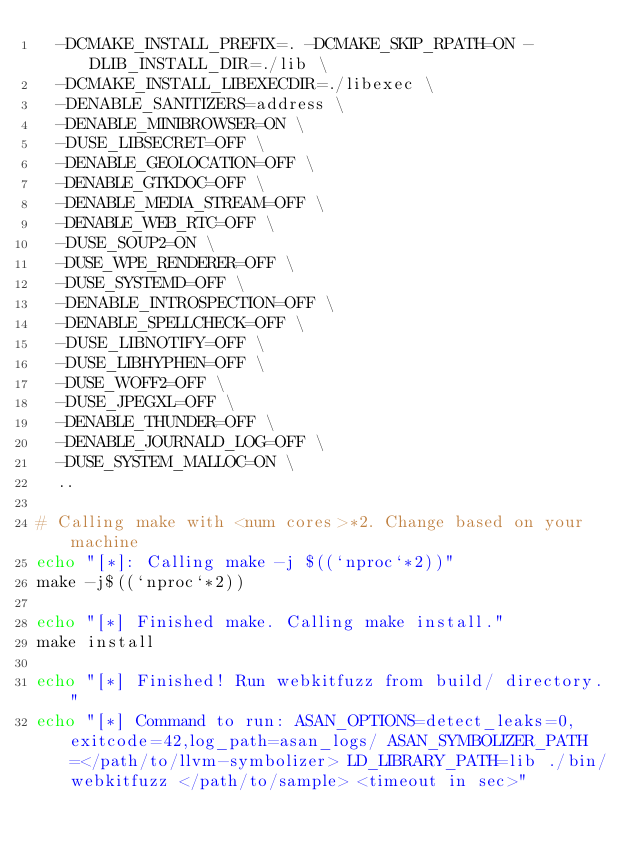<code> <loc_0><loc_0><loc_500><loc_500><_Bash_>  -DCMAKE_INSTALL_PREFIX=. -DCMAKE_SKIP_RPATH=ON -DLIB_INSTALL_DIR=./lib \
  -DCMAKE_INSTALL_LIBEXECDIR=./libexec \
  -DENABLE_SANITIZERS=address \
  -DENABLE_MINIBROWSER=ON \
  -DUSE_LIBSECRET=OFF \
  -DENABLE_GEOLOCATION=OFF \
  -DENABLE_GTKDOC=OFF \
  -DENABLE_MEDIA_STREAM=OFF \
  -DENABLE_WEB_RTC=OFF \
  -DUSE_SOUP2=ON \
  -DUSE_WPE_RENDERER=OFF \
  -DUSE_SYSTEMD=OFF \
  -DENABLE_INTROSPECTION=OFF \
  -DENABLE_SPELLCHECK=OFF \
  -DUSE_LIBNOTIFY=OFF \
  -DUSE_LIBHYPHEN=OFF \
  -DUSE_WOFF2=OFF \
  -DUSE_JPEGXL=OFF \
  -DENABLE_THUNDER=OFF \
  -DENABLE_JOURNALD_LOG=OFF \
  -DUSE_SYSTEM_MALLOC=ON \
  ..

# Calling make with <num cores>*2. Change based on your machine
echo "[*]: Calling make -j $((`nproc`*2))"
make -j$((`nproc`*2))

echo "[*] Finished make. Calling make install."
make install

echo "[*] Finished! Run webkitfuzz from build/ directory."
echo "[*] Command to run: ASAN_OPTIONS=detect_leaks=0,exitcode=42,log_path=asan_logs/ ASAN_SYMBOLIZER_PATH=</path/to/llvm-symbolizer> LD_LIBRARY_PATH=lib ./bin/webkitfuzz </path/to/sample> <timeout in sec>"
</code> 